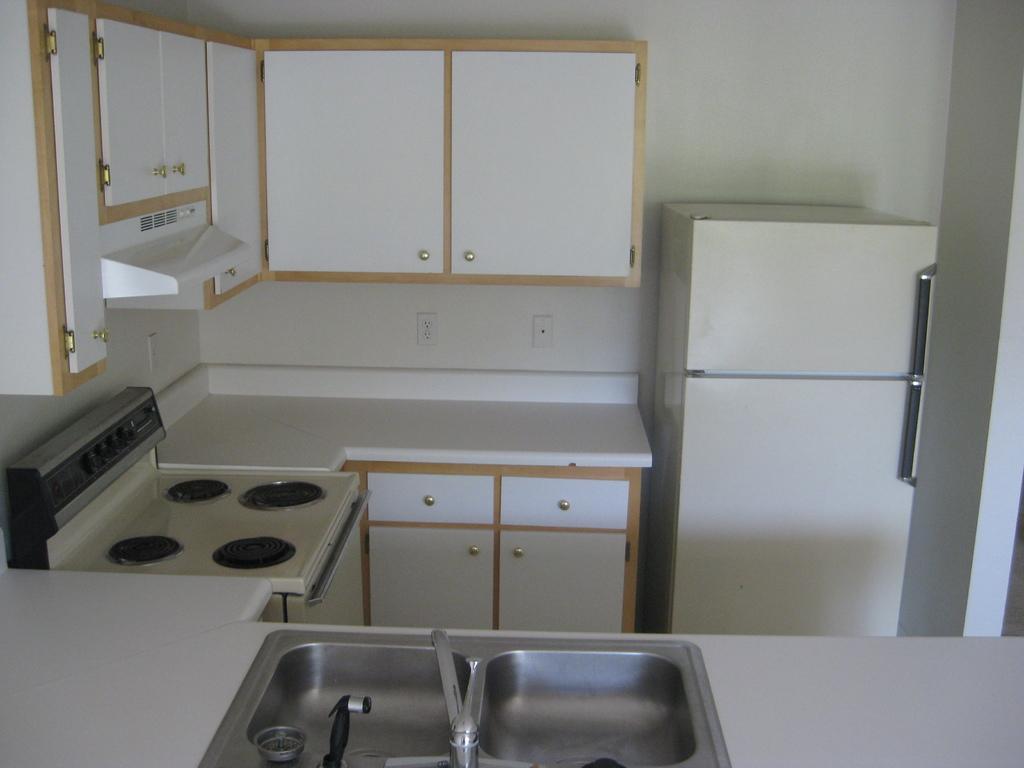How would you summarize this image in a sentence or two? At the bottom of the image there is a platform, sinks, taps and one bowl type object. In the background there is a wall, fridge, chimney, electric stove, cupboards and switch boards. 